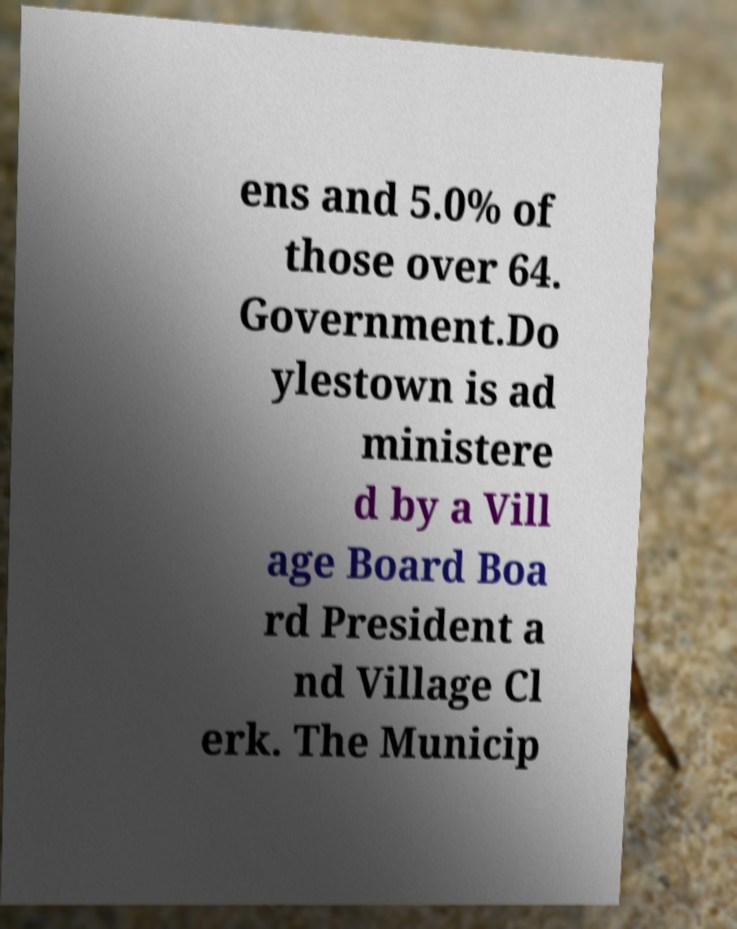Could you assist in decoding the text presented in this image and type it out clearly? ens and 5.0% of those over 64. Government.Do ylestown is ad ministere d by a Vill age Board Boa rd President a nd Village Cl erk. The Municip 